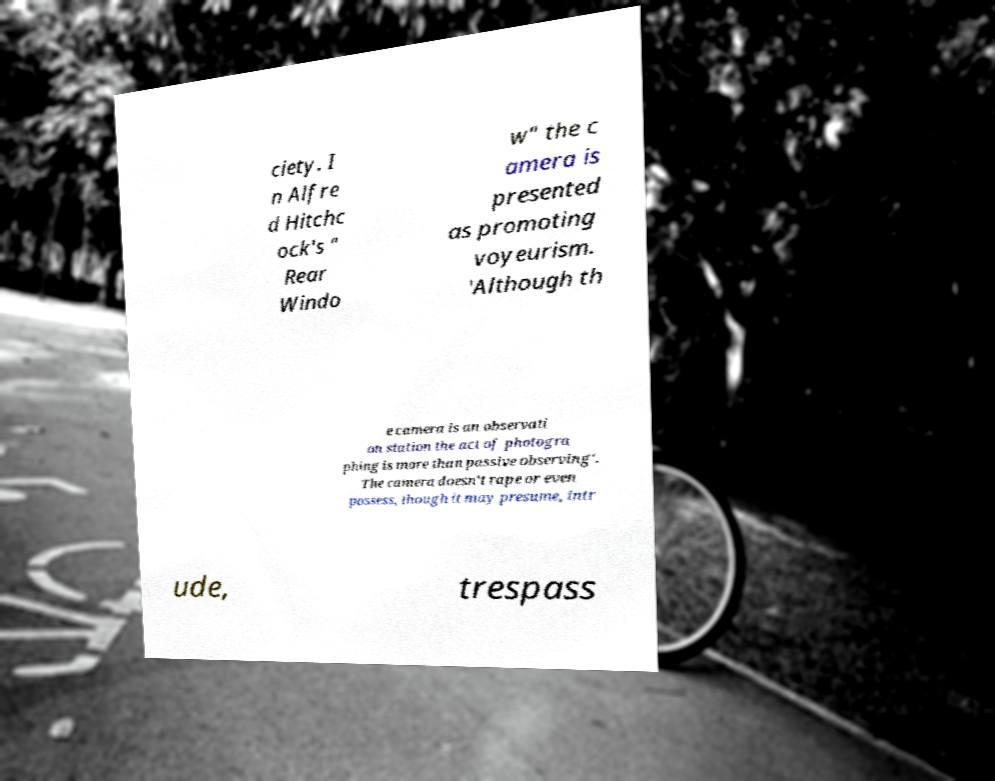Could you extract and type out the text from this image? ciety. I n Alfre d Hitchc ock's " Rear Windo w" the c amera is presented as promoting voyeurism. 'Although th e camera is an observati on station the act of photogra phing is more than passive observing'. The camera doesn't rape or even possess, though it may presume, intr ude, trespass 